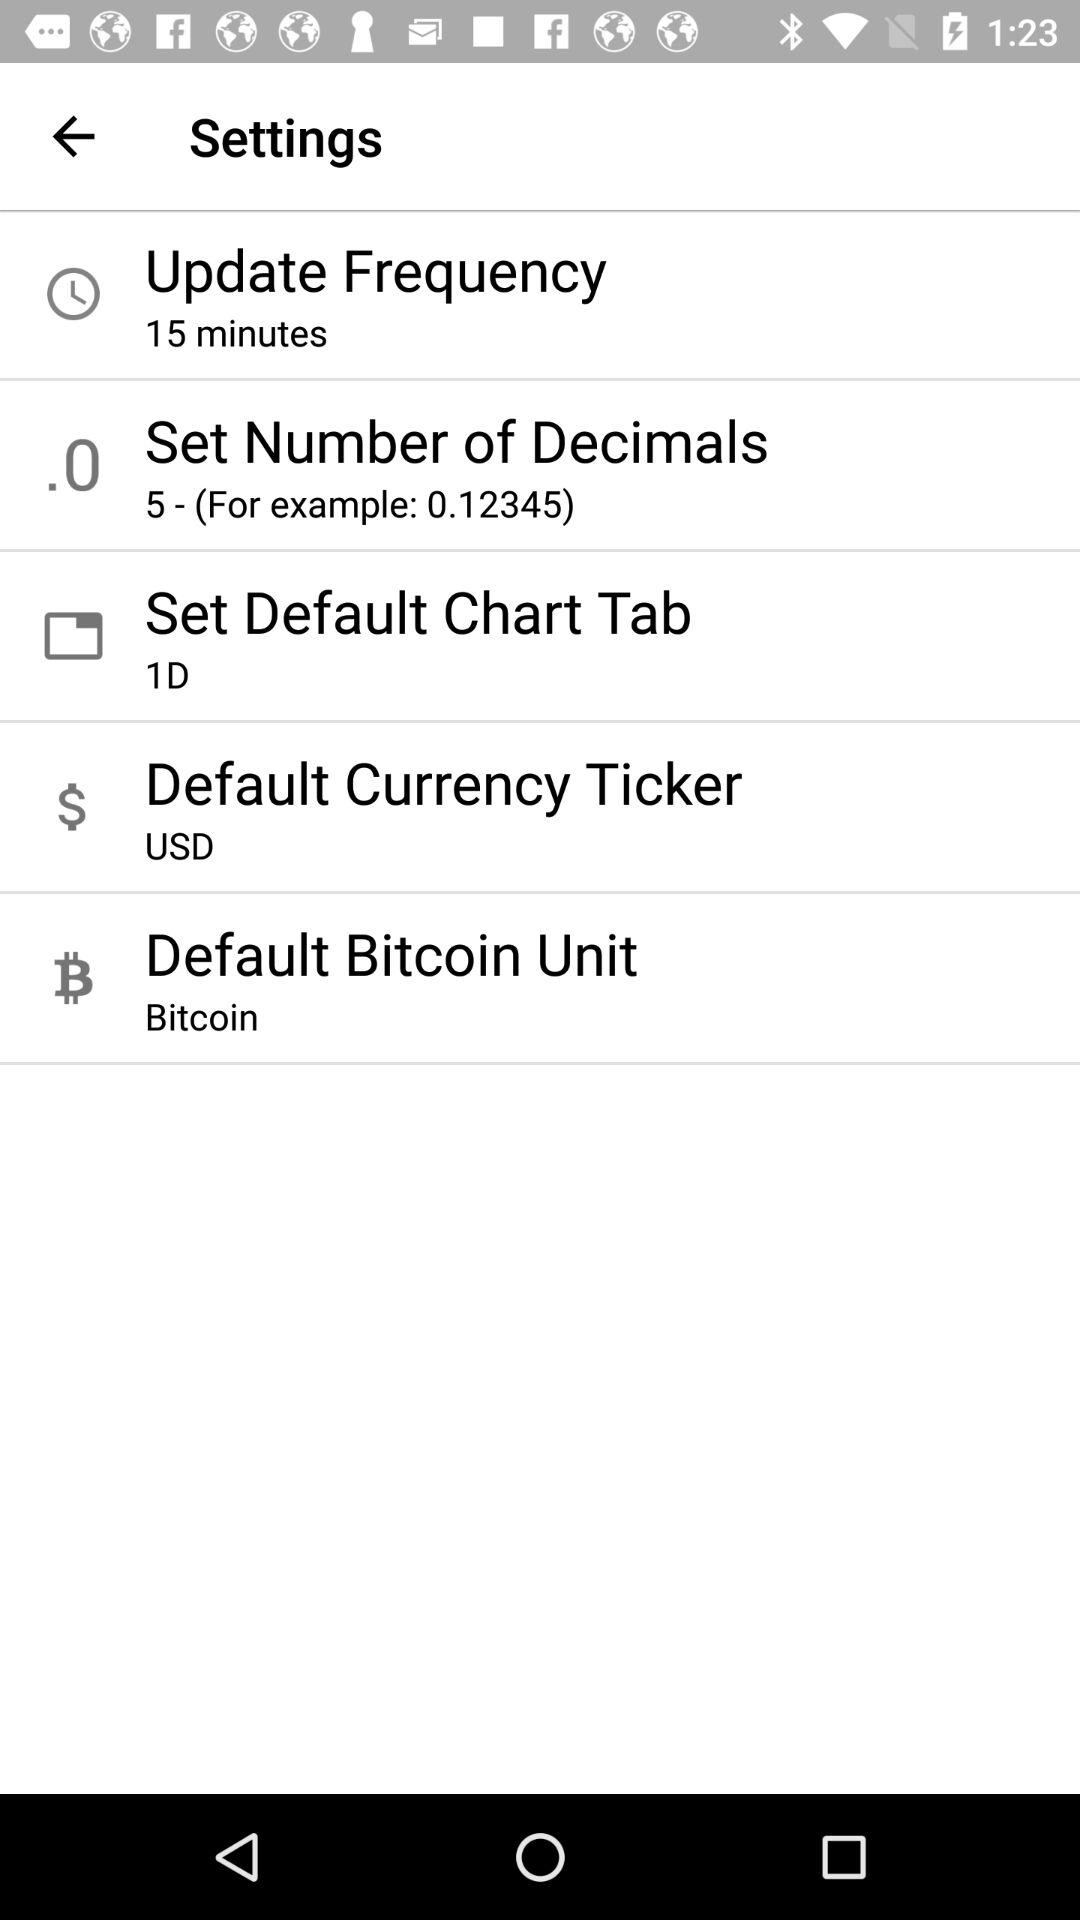What's the setting for the default chart tab? The setting for the default chart tab is "1D". 